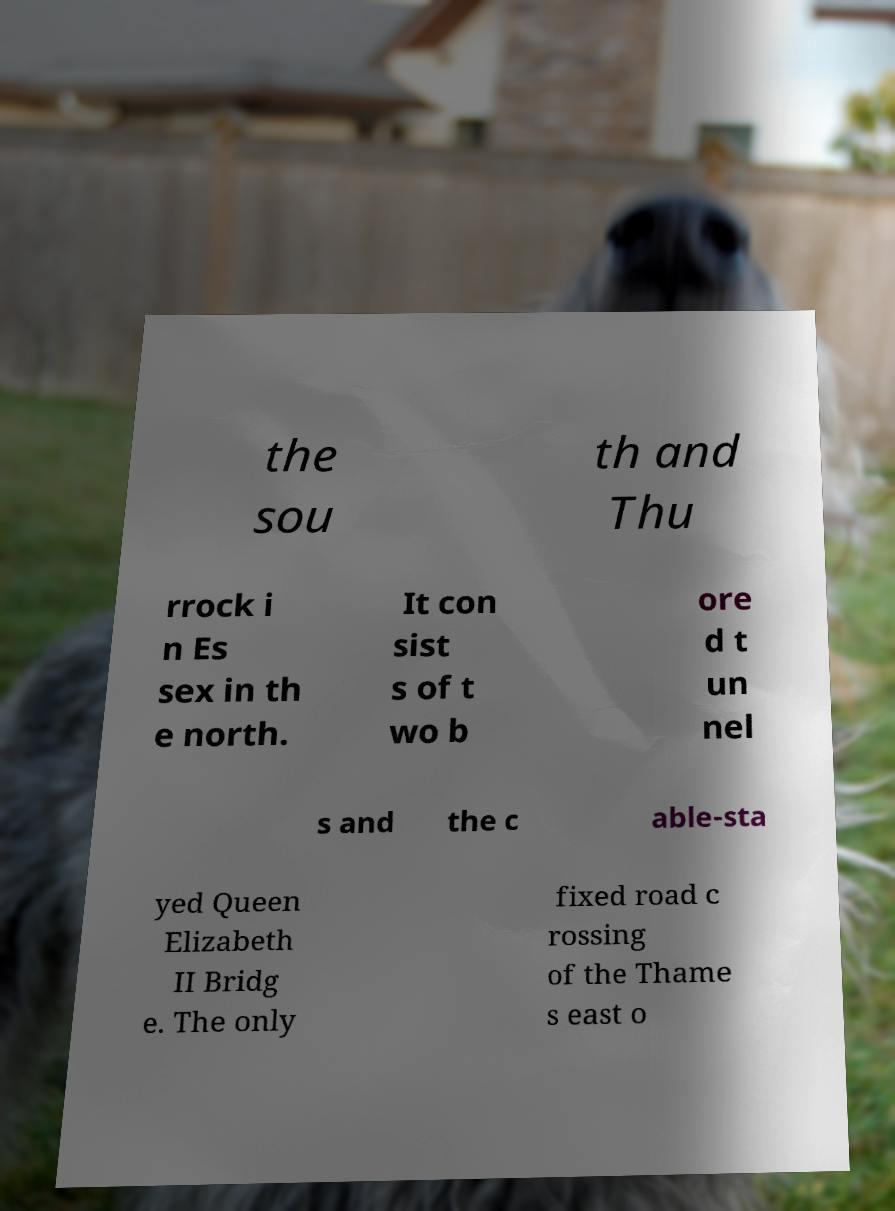For documentation purposes, I need the text within this image transcribed. Could you provide that? the sou th and Thu rrock i n Es sex in th e north. It con sist s of t wo b ore d t un nel s and the c able-sta yed Queen Elizabeth II Bridg e. The only fixed road c rossing of the Thame s east o 